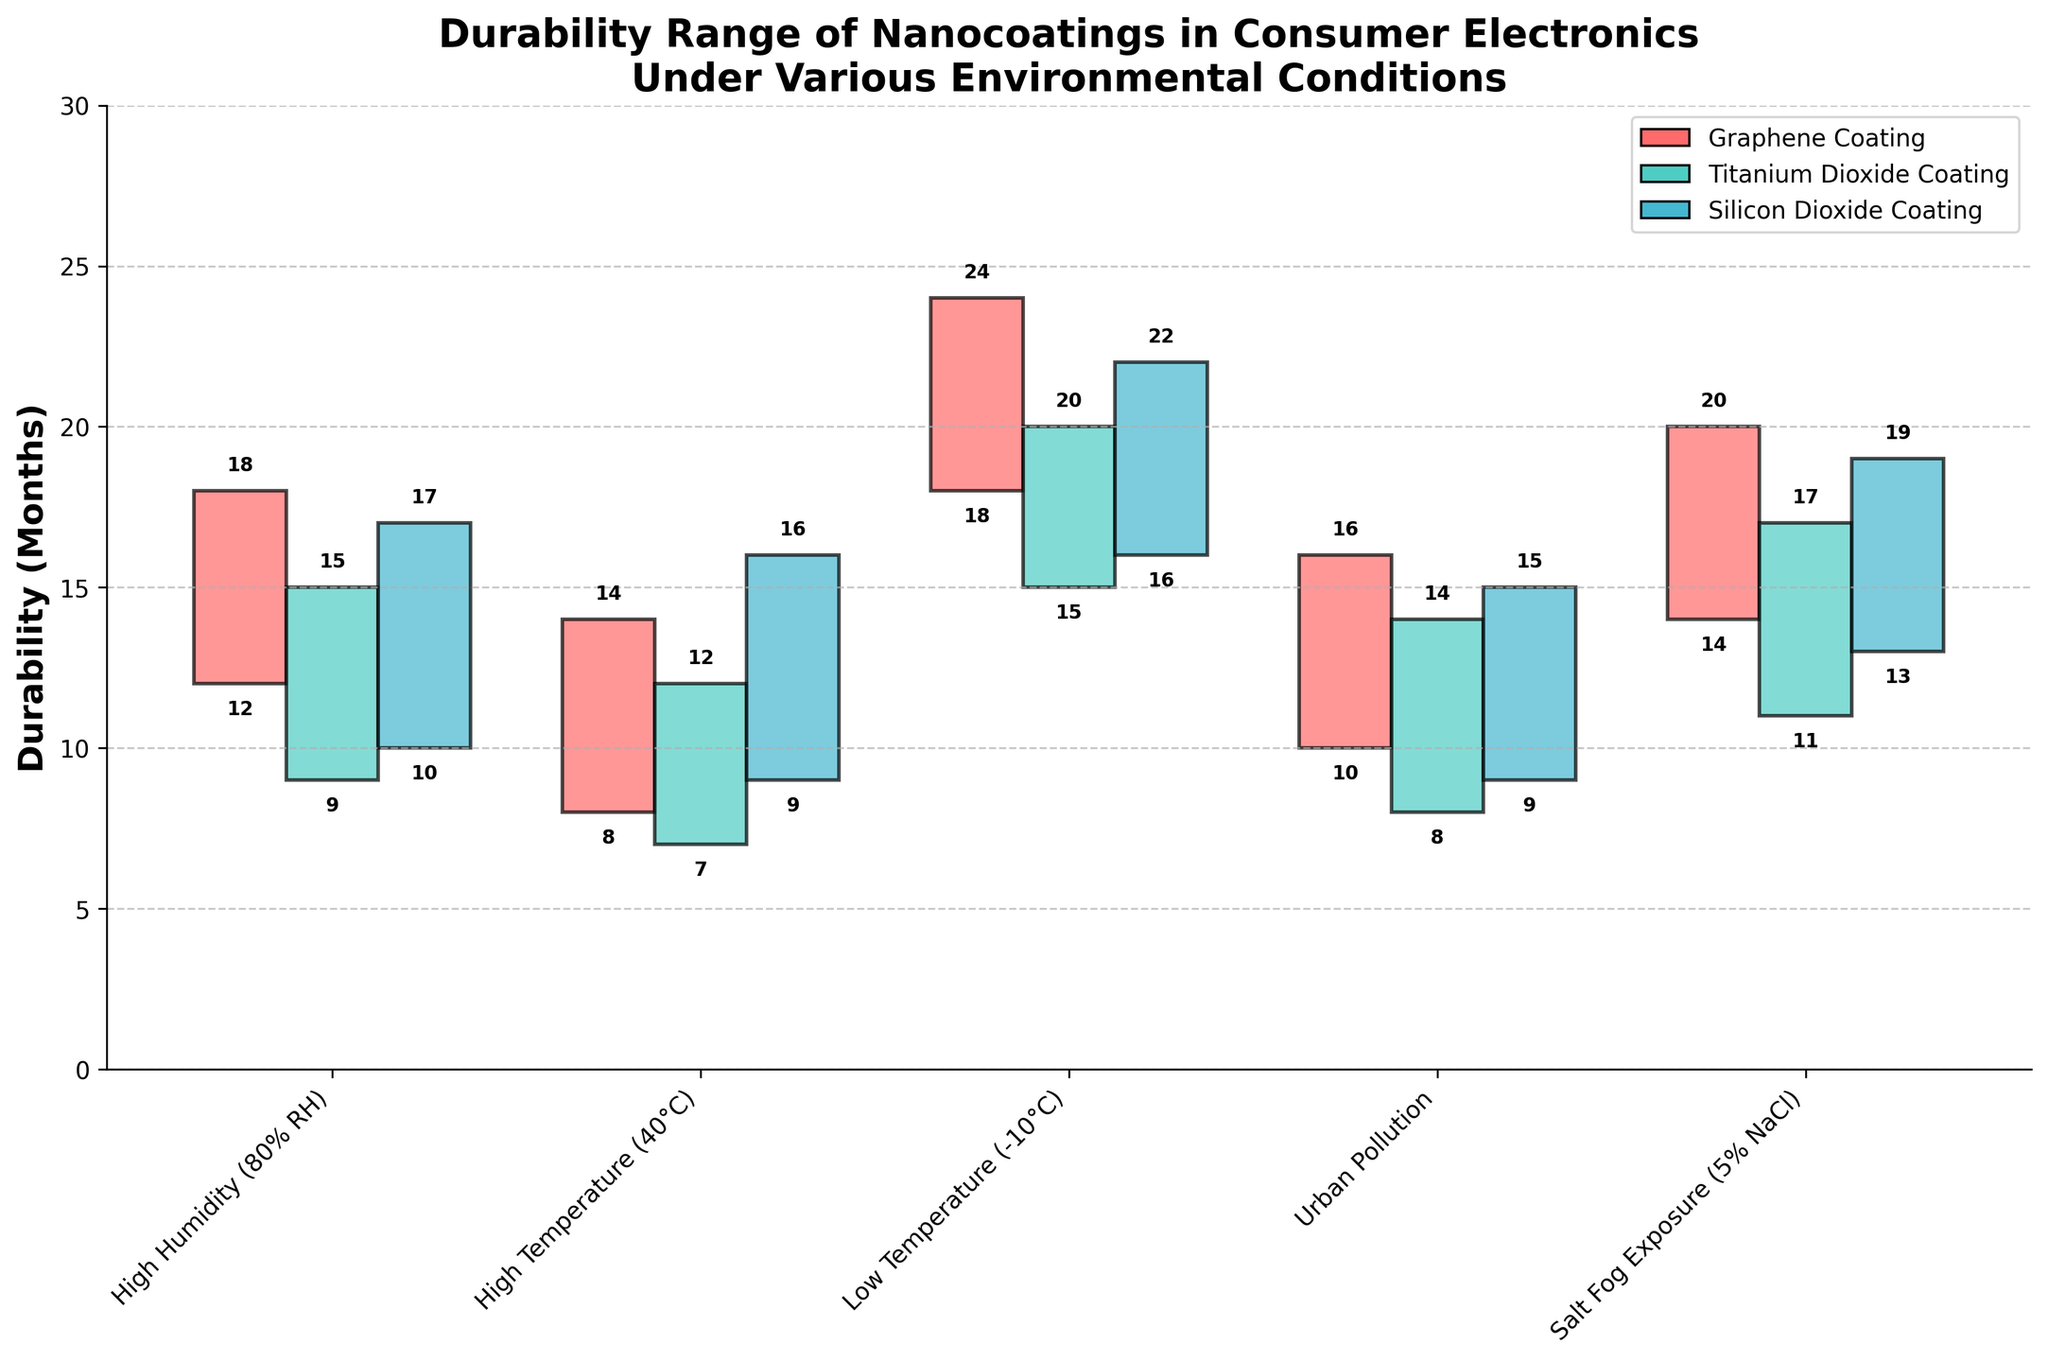What's the title of the figure? The title is displayed at the top center of the chart
Answer: Durability Range of Nanocoatings in Consumer Electronics Under Various Environmental Conditions What is the minimum durability for the Graphene Coating under High Humidity (80% RH)? Identify the Graphene Coating bar under High Humidity and look at the value indicated at the lower end
Answer: 12 months Which nanocoating has the highest minimum durability under Low Temperature (-10°C)? Compare the minimum durability values of all coatings under Low Temperature
Answer: Graphene Coating, 18 months What is the range of durability for Silicon Dioxide Coating under Salt Fog Exposure (5% NaCl)? Subtract the min durability from max durability (19 - 13)
Answer: 6 months Which nanocoating has the widest durability range under High Temperature (40°C)? Compare (Max - Min) for all coatings under High Temperature
Answer: Silicon Dioxide Coating, 7 months How does the durability range of Titanium Dioxide Coating compare between High Humidity and Urban Pollution? Compute the ranges (High Humidity: 15 - 9 = 6, Urban Pollution: 14 - 8 = 6)
Answer: Equal, both 6 months What is the average minimum durability for all coatings under Urban Pollution? Sum the min durability values and divide by the number of coatings ((10 + 8 + 9) / 3)
Answer: 9 months Which environmental condition gives the highest maximum durability for Silicon Dioxide Coating? Check the max values for Silicon Dioxide Coating under all conditions and find the highest
Answer: Low Temperature (-10°C), 22 months By how many months is the maximum durability of Graphene Coating under Low Temperature (-10°C) greater than that under High Temperature (40°C)? Subtract the maximum durability under High Temperature from that under Low Temperature (24 - 14)
Answer: 10 months 